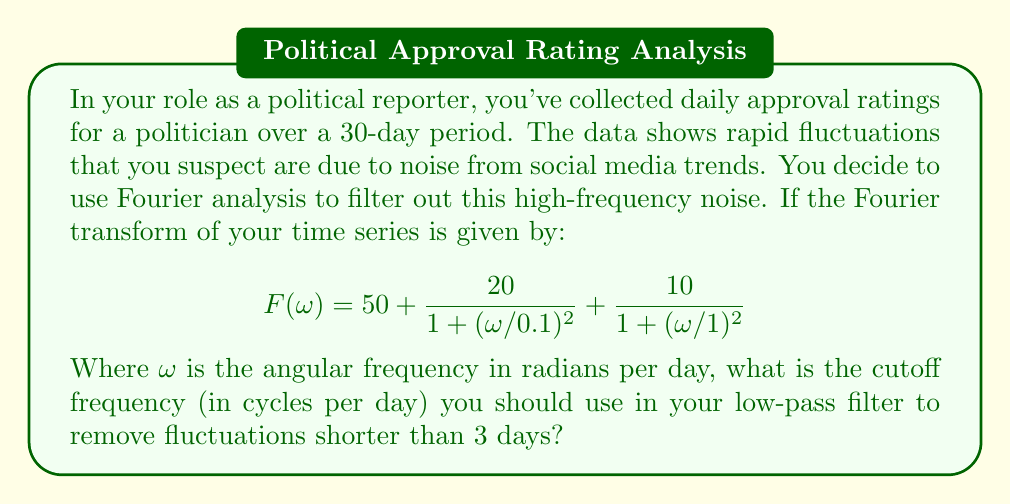Can you answer this question? To solve this problem, we need to follow these steps:

1) First, let's understand what the question is asking. We need to find a cutoff frequency that will remove fluctuations shorter than 3 days. This means we want to keep cycles that are 3 days or longer.

2) The relationship between period (T) and frequency (f) is:

   $f = \frac{1}{T}$

3) For a 3-day period:

   $f = \frac{1}{3}$ cycles per day

4) This is our cutoff frequency in cycles per day. However, the Fourier transform is given in terms of angular frequency $\omega$ in radians per day. We need to convert:

   $\omega = 2\pi f$

5) Substituting our cutoff frequency:

   $\omega_c = 2\pi \cdot \frac{1}{3} = \frac{2\pi}{3}$ radians per day

6) This $\omega_c$ is the angular frequency corresponding to a 3-day period. Any frequency higher than this (which corresponds to a shorter period) should be filtered out.

7) Therefore, the cutoff frequency for the low-pass filter should be $\frac{1}{3}$ cycles per day.
Answer: $\frac{1}{3}$ cycles per day 